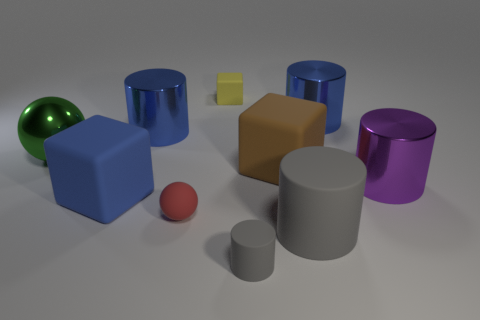Subtract all cubes. How many objects are left? 7 Add 8 tiny red spheres. How many tiny red spheres are left? 9 Add 2 blue shiny cylinders. How many blue shiny cylinders exist? 4 Subtract 1 green spheres. How many objects are left? 9 Subtract all green objects. Subtract all yellow cubes. How many objects are left? 8 